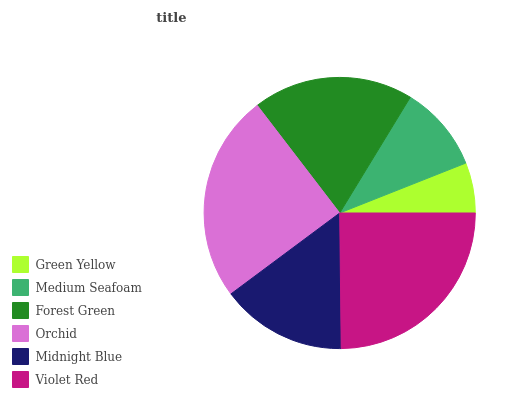Is Green Yellow the minimum?
Answer yes or no. Yes. Is Violet Red the maximum?
Answer yes or no. Yes. Is Medium Seafoam the minimum?
Answer yes or no. No. Is Medium Seafoam the maximum?
Answer yes or no. No. Is Medium Seafoam greater than Green Yellow?
Answer yes or no. Yes. Is Green Yellow less than Medium Seafoam?
Answer yes or no. Yes. Is Green Yellow greater than Medium Seafoam?
Answer yes or no. No. Is Medium Seafoam less than Green Yellow?
Answer yes or no. No. Is Forest Green the high median?
Answer yes or no. Yes. Is Midnight Blue the low median?
Answer yes or no. Yes. Is Midnight Blue the high median?
Answer yes or no. No. Is Medium Seafoam the low median?
Answer yes or no. No. 